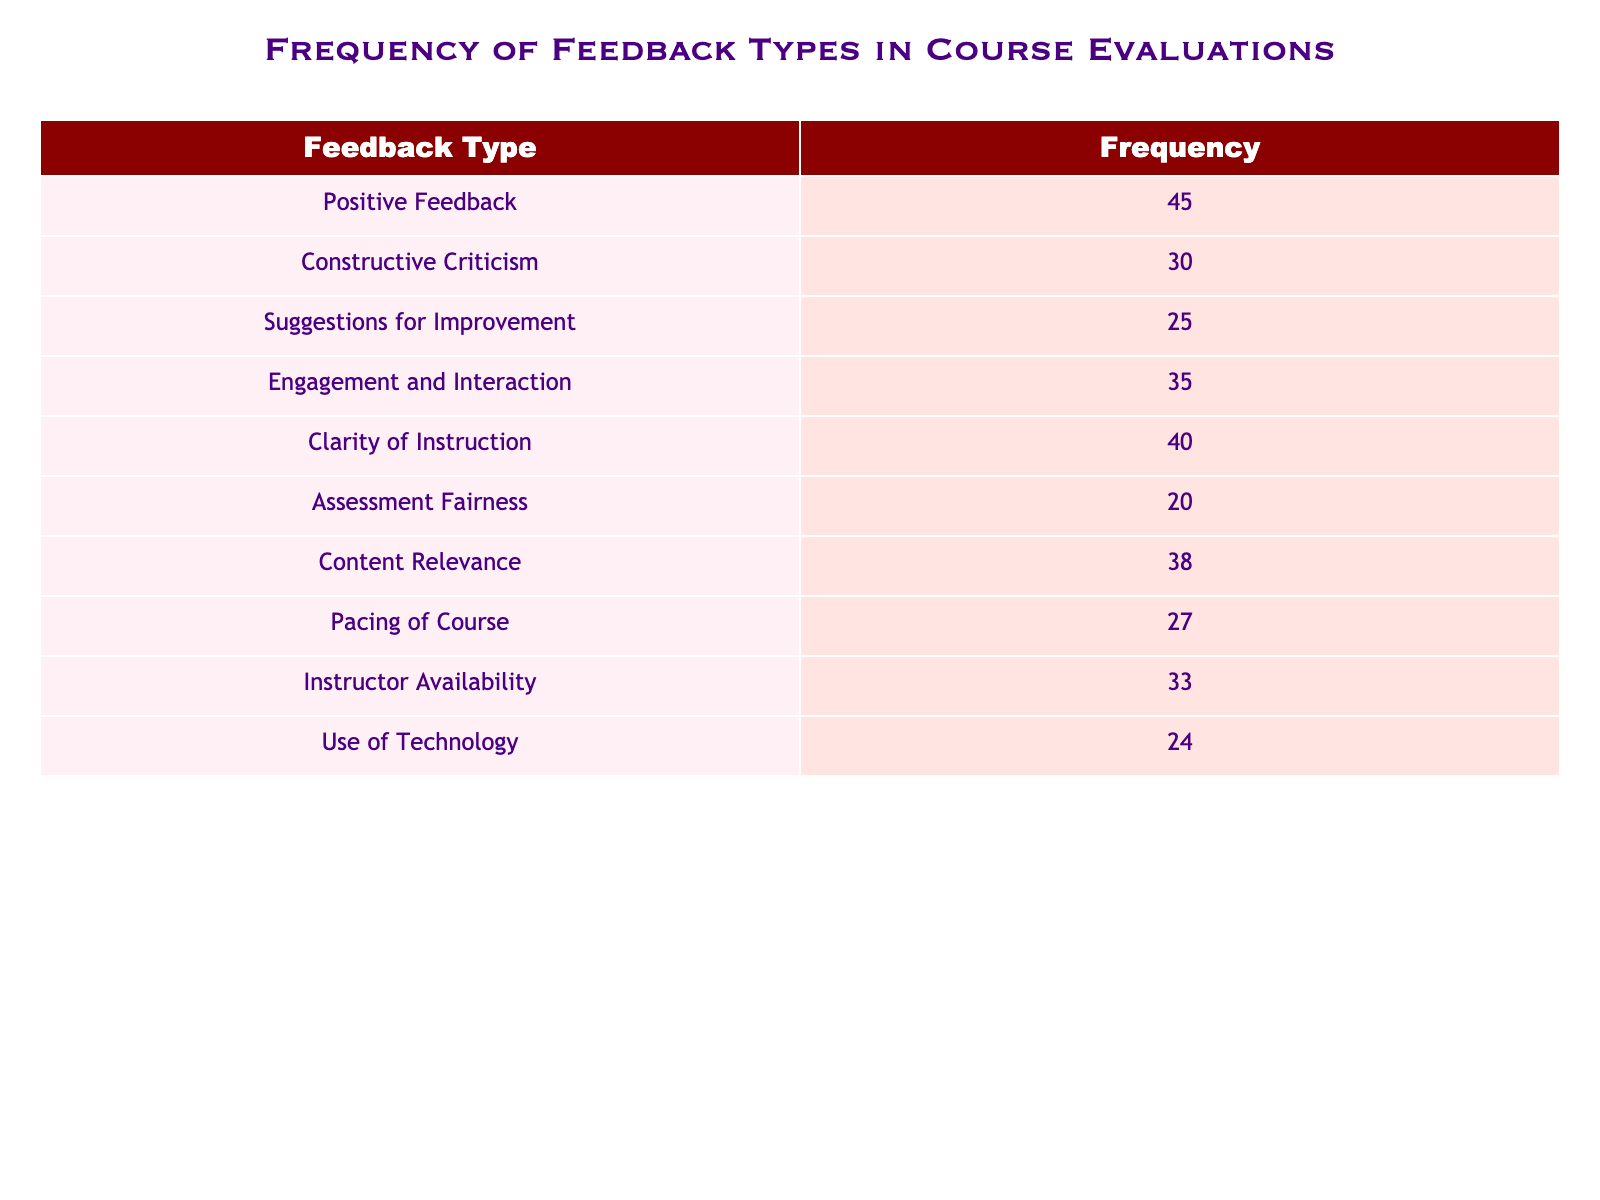What is the frequency of Positive Feedback? The table clearly lists the frequency for each feedback type. For Positive Feedback, it states the frequency as 45.
Answer: 45 Which feedback type received the lowest frequency? By reviewing the frequencies listed, Assessment Fairness has the lowest value at 20 compared to others in the table.
Answer: Assessment Fairness What is the sum of the frequencies for Suggestions for Improvement and Engagement and Interaction? To find the sum, we need to add the frequencies: Suggestions for Improvement is 25 and Engagement and Interaction is 35. Therefore, 25 + 35 equals 60.
Answer: 60 Is the frequency of Clarity of Instruction greater than the frequency of Pacing of Course? The frequency for Clarity of Instruction is 40, while for Pacing of Course it is 27. Since 40 is greater than 27, the statement is true.
Answer: Yes What is the average frequency of all the feedback types listed? First, we sum all the frequencies: 45 + 30 + 25 + 35 + 40 + 20 + 38 + 27 + 33 + 24 =  367. There are 10 feedback types, so we divide 367 by 10, resulting in an average frequency of 36.7.
Answer: 36.7 Which feedback type received more feedback: Use of Technology or Assessment Fairness? The frequency for Use of Technology is 24, and for Assessment Fairness, it is 20. Since 24 is greater than 20, Use of Technology received more feedback.
Answer: Use of Technology What is the difference in frequency between Engagement and Interaction and Clarity of Instruction? The frequency for Engagement and Interaction is 35 and for Clarity of Instruction is 40. To find the difference, we subtract the smaller value from the larger one: 40 - 35 equals 5.
Answer: 5 How many feedback types received frequencies above 30? By examining the table, we can count the values above 30 which are Positive Feedback (45), Engagement and Interaction (35), Clarity of Instruction (40), Instructor Availability (33), and Content Relevance (38). There are 5 feedback types.
Answer: 5 Which feedback type had a frequency that was not over 25? Looking at the table, the feedback types with frequencies below or equal to 25 are Assessment Fairness (20) and Use of Technology (24).
Answer: Assessment Fairness and Use of Technology 